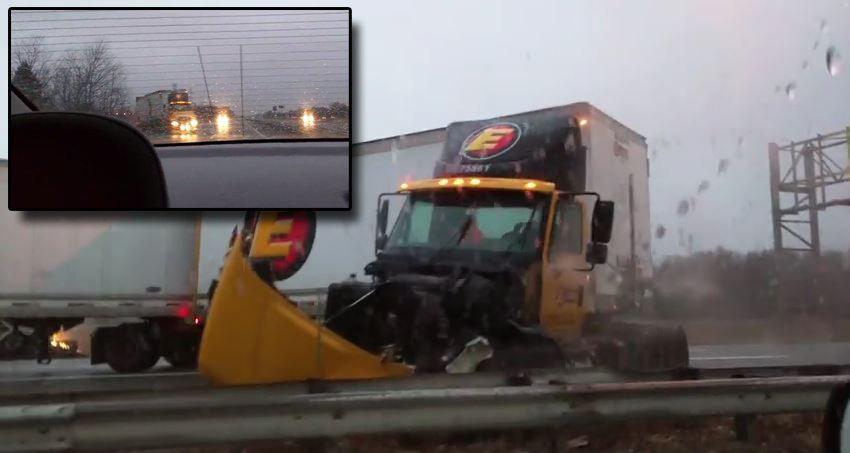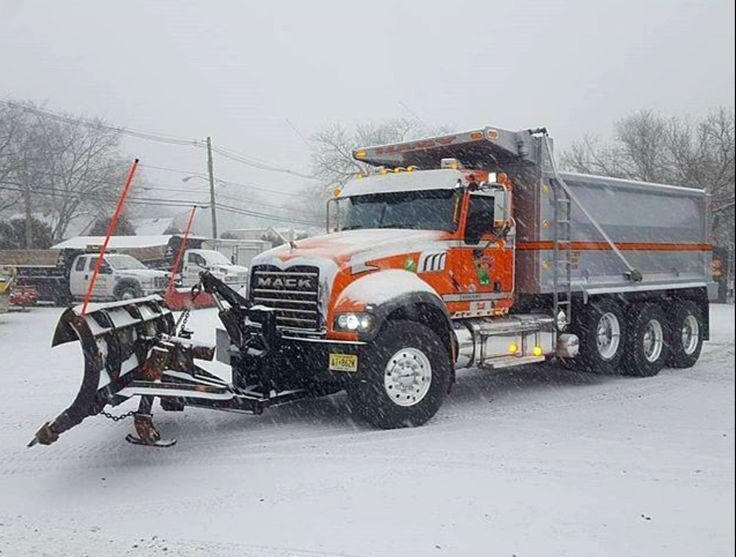The first image is the image on the left, the second image is the image on the right. Examine the images to the left and right. Is the description "One of the images shows two plows and the other shows only one plow." accurate? Answer yes or no. No. 